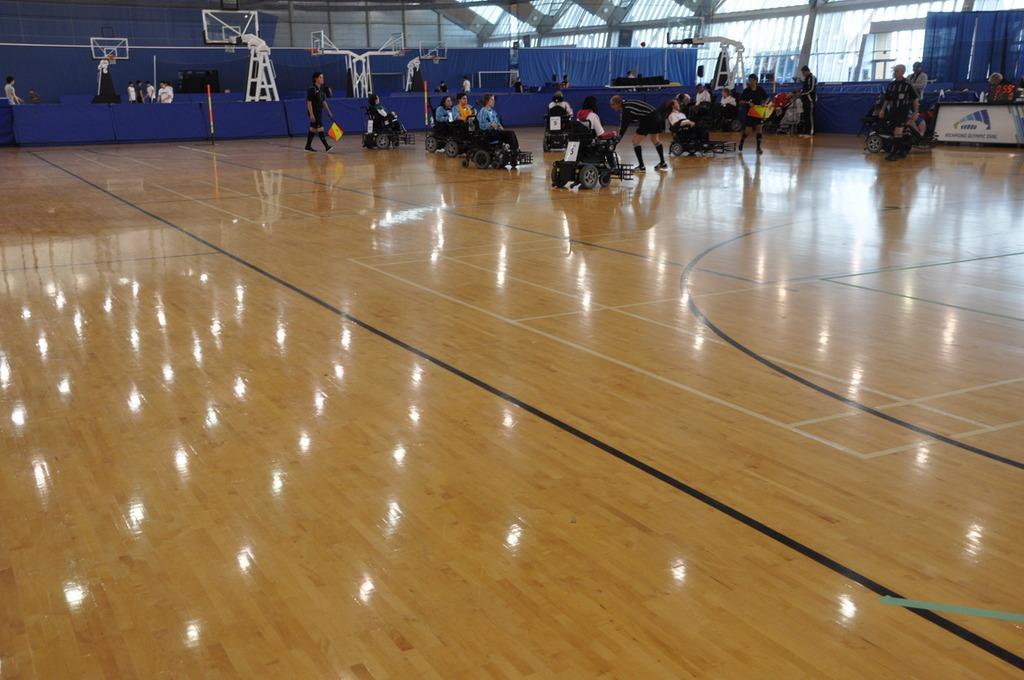How would you summarize this image in a sentence or two? In this image I can see group of people sitting on the wheelchair and I can see few persons standing. Background I can see few blue colored curtains. 